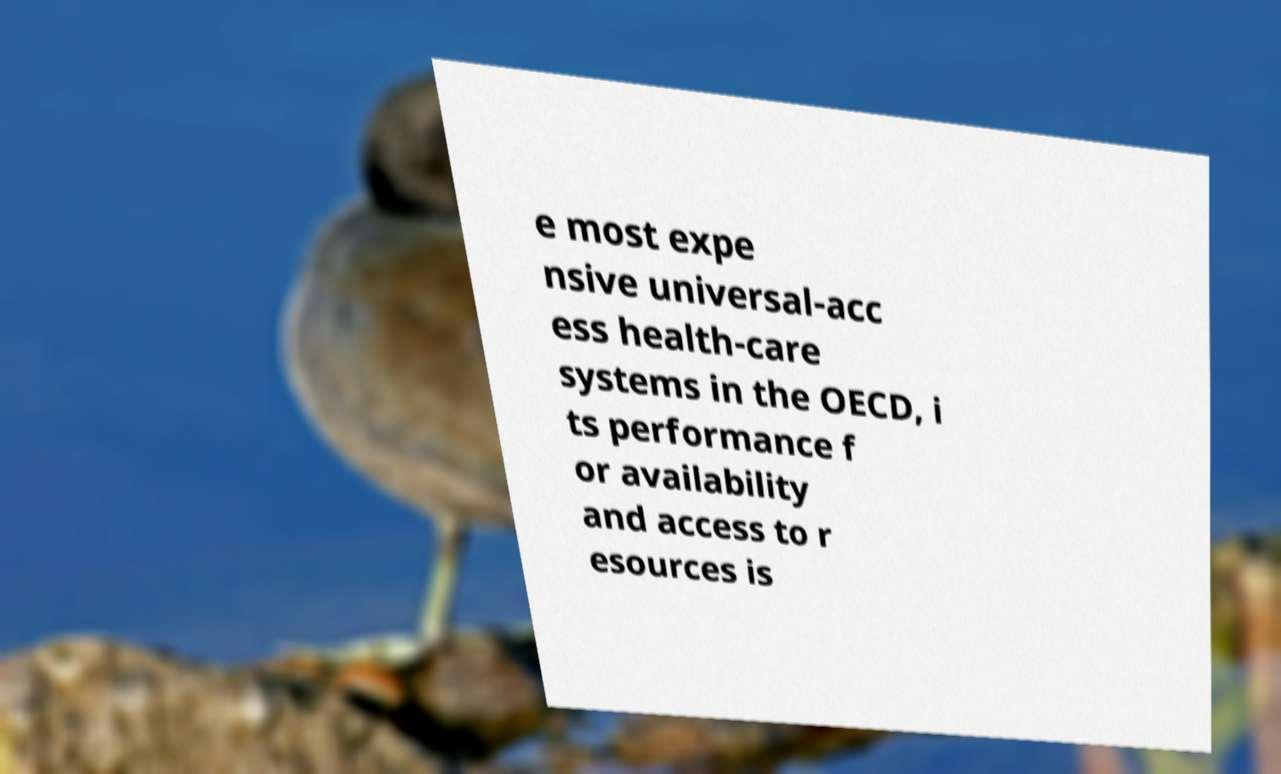What messages or text are displayed in this image? I need them in a readable, typed format. e most expe nsive universal-acc ess health-care systems in the OECD, i ts performance f or availability and access to r esources is 